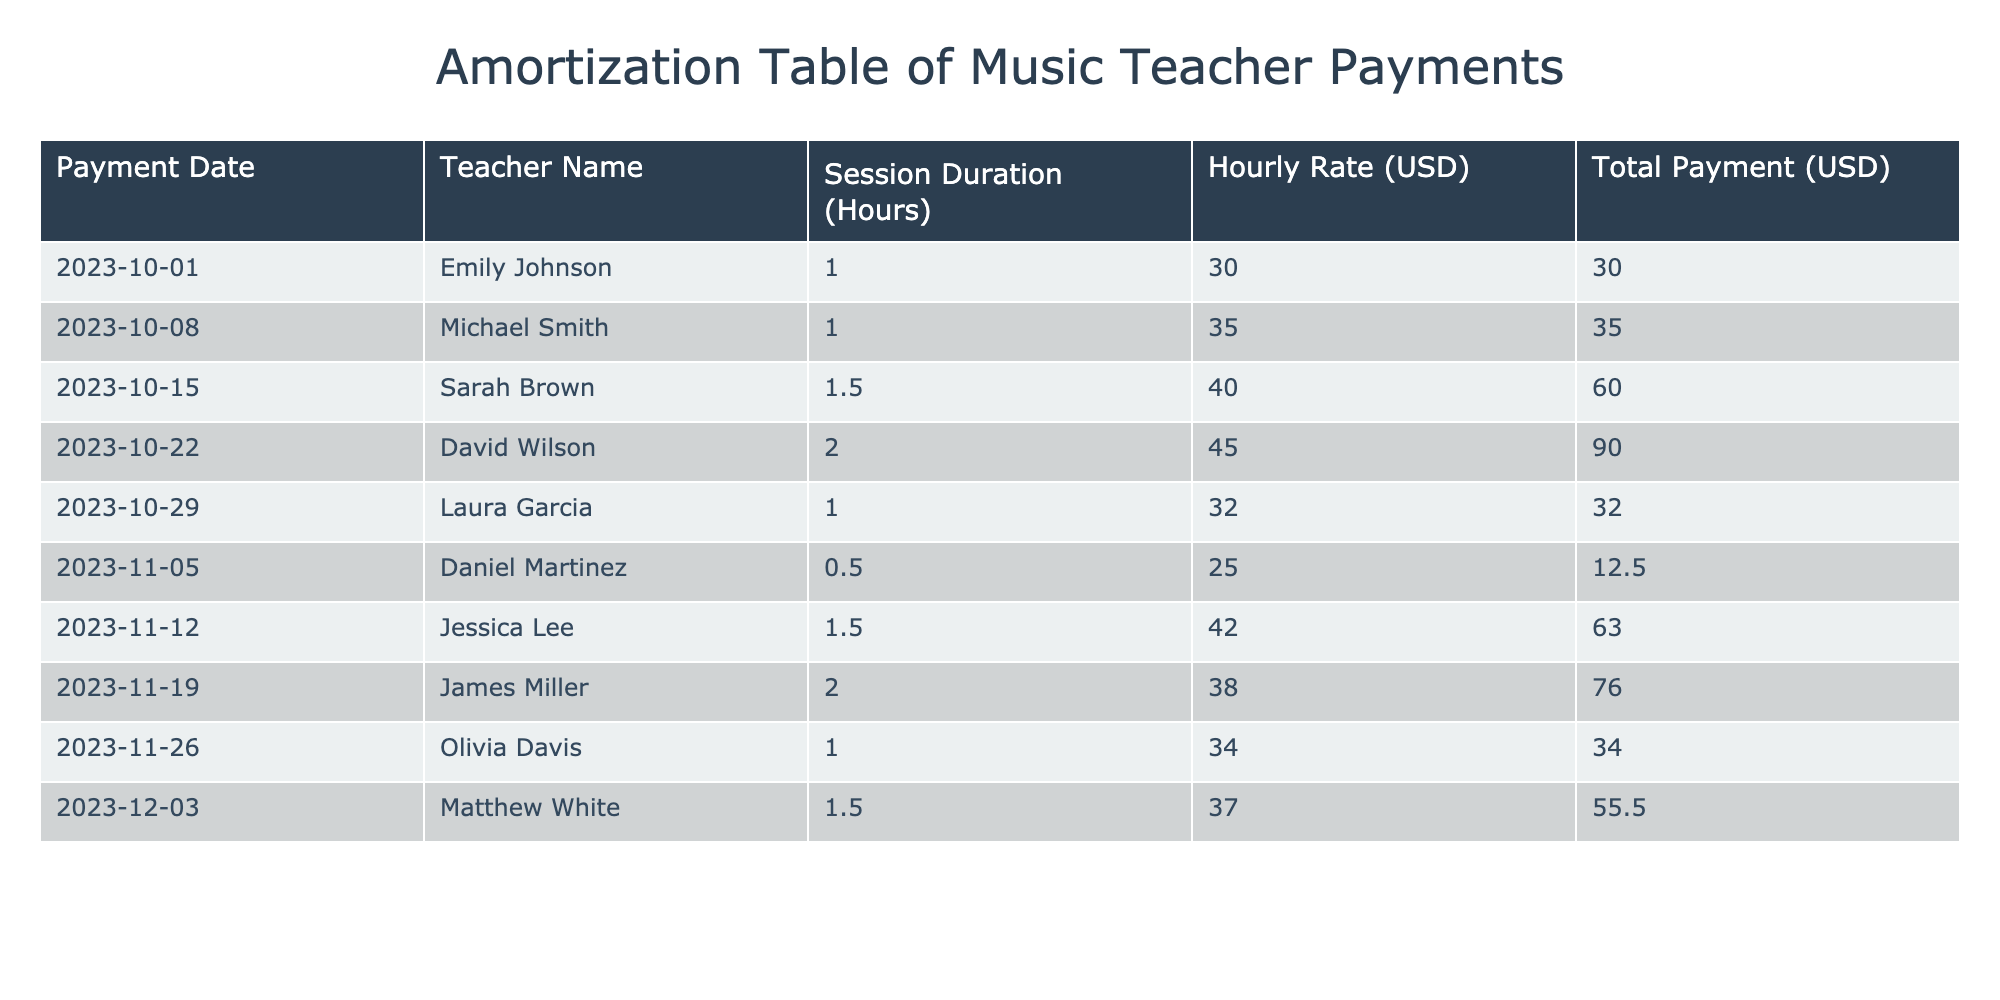What is the hourly rate of Sarah Brown? The hourly rate of Sarah Brown is listed in the table under the "Hourly Rate (USD)" column next to her name. It shows 40 USD.
Answer: 40 USD Who is the teacher with the highest total payment? The total payments can be compared by examining the "Total Payment (USD)" column. David Wilson has the highest total payment of 90 USD.
Answer: David Wilson What is the average hourly rate of all teachers listed? To find the average hourly rate, sum all the hourly rates: (30 + 35 + 40 + 45 + 32 + 25 + 42 + 38 + 34 + 37) =  378 USD. Then divide by the number of teachers, which is 10: 378 / 10 = 37.8.
Answer: 37.8 USD Did Emily Johnson's payment date occur before or after November 1, 2023? The payment date for Emily Johnson is October 1, 2023. Since this date is before November 1, 2023, the statement is true.
Answer: Yes How much total payment was made to Laura Garcia and Jessica Lee combined? To get the total payment for Laura Garcia and Jessica Lee, add their payments: Laura Garcia has a payment of 32 USD and Jessica Lee has a payment of 63 USD. So, 32 + 63 = 95 USD.
Answer: 95 USD Which teacher had a session duration of 0.5 hours, and what was their hourly rate? Browsing the table, Daniel Martinez is listed with a session duration of 0.5 hours, and his hourly rate is 25 USD.
Answer: Daniel Martinez, 25 USD Is the total payment for Matthew White greater than 50 USD? Looking at the table, Matthew White has a total payment of 55.5 USD. Since 55.5 is greater than 50, the statement is true.
Answer: Yes What was the range of total payments made in the table? To find the range, identify the maximum and minimum payments. The maximum payment is 90 USD (David Wilson), and the minimum payment is 12.5 USD (Daniel Martinez). The range is then 90 - 12.5 = 77.5 USD.
Answer: 77.5 USD How many sessions were conducted by teachers charging more than 40 USD per hour? Checking the hourly rates, the teachers charging more than 40 USD are Sarah Brown, David Wilson, Jessica Lee, and Matthew White, totaling 4 sessions (1.5 hours for Sarah, 2 hours for David, 1.5 hours for Jessica, and 1.5 hours for Matthew).
Answer: 4 sessions 